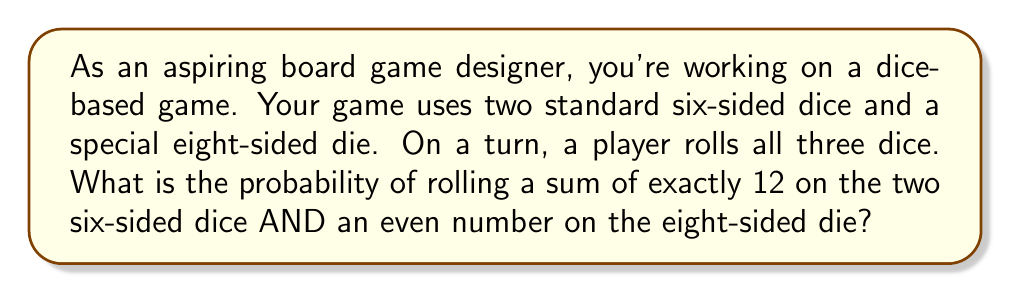Can you answer this question? Let's break this down step-by-step:

1) First, let's calculate the probability of rolling a sum of 12 on two six-sided dice:
   - The possible combinations to get a sum of 12 are: (6,6), (5,7), (4,8), (3,9), (2,10), (1,11)
   - There are 6 favorable outcomes out of 36 possible outcomes (6 x 6 = 36)
   - So, the probability of rolling a 12 is: $P(12) = \frac{6}{36} = \frac{1}{6}$

2) Now, let's calculate the probability of rolling an even number on an eight-sided die:
   - The even numbers on an eight-sided die are 2, 4, 6, and 8
   - There are 4 favorable outcomes out of 8 possible outcomes
   - So, the probability of rolling an even number is: $P(even) = \frac{4}{8} = \frac{1}{2}$

3) Since we need both events to occur simultaneously, and the events are independent, we multiply the probabilities:

   $P(12 \text{ AND } even) = P(12) \times P(even) = \frac{1}{6} \times \frac{1}{2} = \frac{1}{12}$

Therefore, the probability of rolling a sum of 12 on the two six-sided dice AND an even number on the eight-sided die is $\frac{1}{12}$.
Answer: $\frac{1}{12}$ 